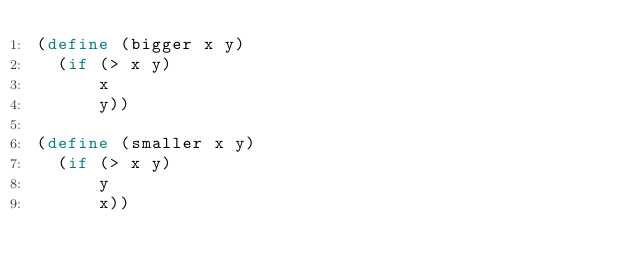Convert code to text. <code><loc_0><loc_0><loc_500><loc_500><_Scheme_>(define (bigger x y)
  (if (> x y)
      x
      y))

(define (smaller x y)
  (if (> x y)
      y
      x))
</code> 